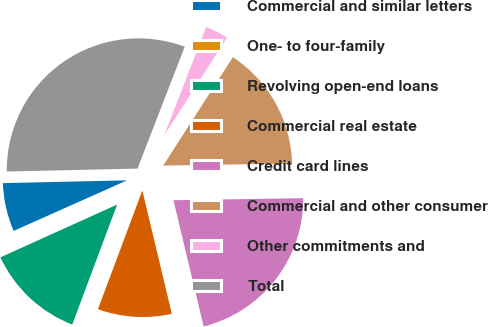Convert chart. <chart><loc_0><loc_0><loc_500><loc_500><pie_chart><fcel>Commercial and similar letters<fcel>One- to four-family<fcel>Revolving open-end loans<fcel>Commercial real estate<fcel>Credit card lines<fcel>Commercial and other consumer<fcel>Other commitments and<fcel>Total<nl><fcel>6.32%<fcel>0.08%<fcel>12.55%<fcel>9.43%<fcel>21.51%<fcel>15.66%<fcel>3.2%<fcel>31.24%<nl></chart> 